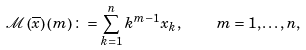<formula> <loc_0><loc_0><loc_500><loc_500>\mathcal { M } \left ( \overline { x } \right ) \left ( m \right ) \colon = \sum _ { k = 1 } ^ { n } k ^ { m - 1 } x _ { k } , \quad m = 1 , \dots , n ,</formula> 